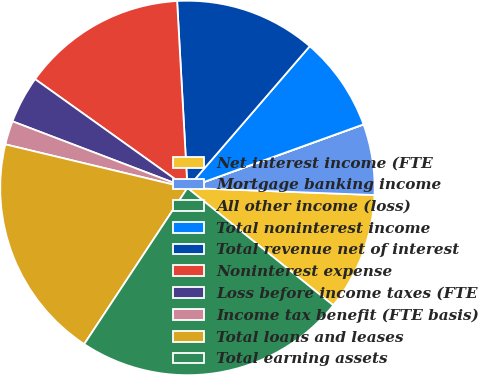Convert chart. <chart><loc_0><loc_0><loc_500><loc_500><pie_chart><fcel>Net interest income (FTE<fcel>Mortgage banking income<fcel>All other income (loss)<fcel>Total noninterest income<fcel>Total revenue net of interest<fcel>Noninterest expense<fcel>Loss before income taxes (FTE<fcel>Income tax benefit (FTE basis)<fcel>Total loans and leases<fcel>Total earning assets<nl><fcel>10.18%<fcel>6.11%<fcel>0.01%<fcel>8.15%<fcel>12.21%<fcel>14.25%<fcel>4.08%<fcel>2.05%<fcel>19.44%<fcel>23.51%<nl></chart> 